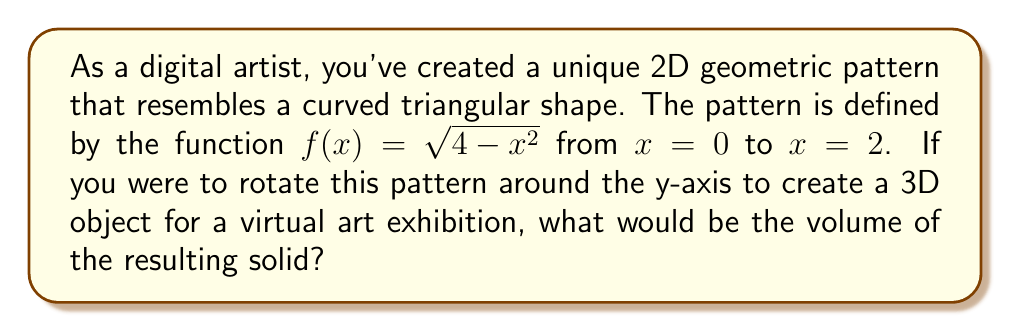Can you answer this question? To find the volume of the solid created by rotating the given 2D pattern around the y-axis, we need to use the method of shell integration. This method is appropriate when rotating around the y-axis.

The steps to solve this problem are:

1) The shell method formula for volume is:

   $$ V = 2\pi \int_a^b x f(x) dx $$

   where $x$ is the distance from the axis of rotation, and $f(x)$ is the function defining the curve.

2) In this case, $f(x) = \sqrt{4-x^2}$, $a=0$, and $b=2$.

3) Substituting these into the formula:

   $$ V = 2\pi \int_0^2 x \sqrt{4-x^2} dx $$

4) This integral is challenging to solve directly, so we'll use a trigonometric substitution:
   Let $x = 2\sin\theta$. Then $dx = 2\cos\theta d\theta$

5) When $x=0$, $\theta=0$, and when $x=2$, $\theta=\frac{\pi}{2}$

6) Substituting:

   $$ V = 2\pi \int_0^{\frac{\pi}{2}} (2\sin\theta) \sqrt{4-(2\sin\theta)^2} (2\cos\theta) d\theta $$

   $$ = 8\pi \int_0^{\frac{\pi}{2}} \sin\theta \sqrt{4-4\sin^2\theta} \cos\theta d\theta $$

   $$ = 8\pi \int_0^{\frac{\pi}{2}} \sin\theta (2\cos\theta) \cos\theta d\theta $$

   $$ = 16\pi \int_0^{\frac{\pi}{2}} \sin\theta \cos^2\theta d\theta $$

7) This can be solved using the substitution $u=\cos\theta$, $du=-\sin\theta d\theta$:

   $$ V = -16\pi \int_1^0 u^2 du = -16\pi [\frac{u^3}{3}]_1^0 = -16\pi (0 - \frac{1}{3}) = \frac{16\pi}{3} $$

Therefore, the volume of the 3D object is $\frac{16\pi}{3}$ cubic units.
Answer: $\frac{16\pi}{3}$ cubic units 